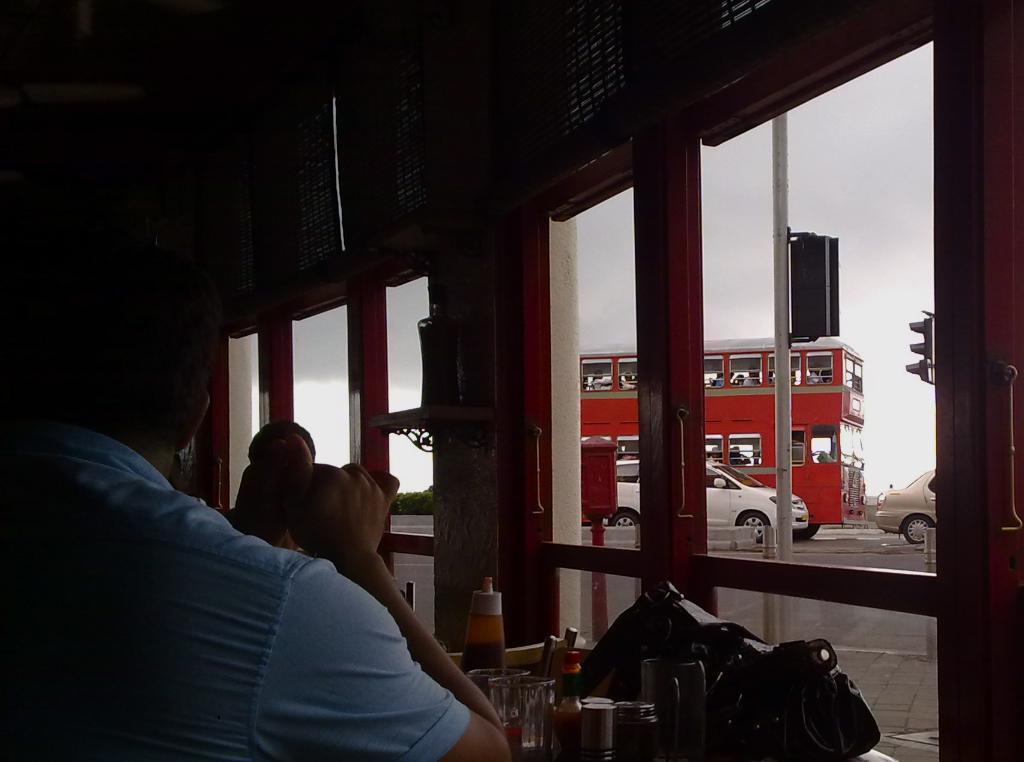In one or two sentences, can you explain what this image depicts? On the left there is a man who is wearing shirt and sitting near to the table. On the table we can see ketchup bottle, sauce bottle, glass, cups, knife holder and bag. Here we can see another man who is standing near to the door. Through the door we can see some people sitting inside the double bus, white car, brown car, plants and traffic signal. Here we can see sky and clouds. In front of the door there is a pipe. 